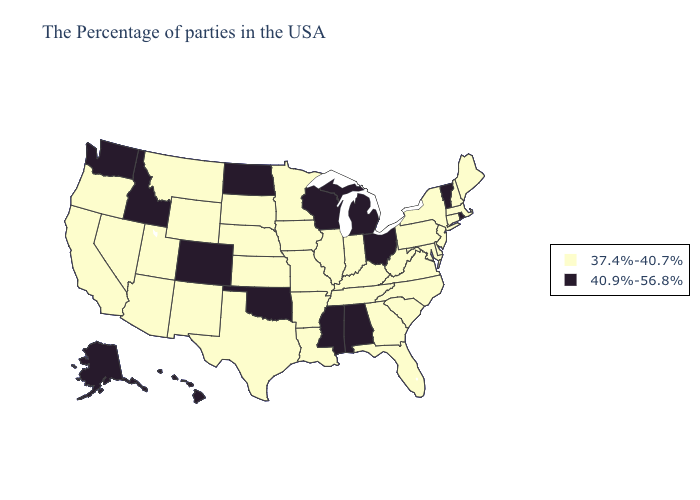Name the states that have a value in the range 37.4%-40.7%?
Answer briefly. Maine, Massachusetts, New Hampshire, Connecticut, New York, New Jersey, Delaware, Maryland, Pennsylvania, Virginia, North Carolina, South Carolina, West Virginia, Florida, Georgia, Kentucky, Indiana, Tennessee, Illinois, Louisiana, Missouri, Arkansas, Minnesota, Iowa, Kansas, Nebraska, Texas, South Dakota, Wyoming, New Mexico, Utah, Montana, Arizona, Nevada, California, Oregon. What is the value of Indiana?
Answer briefly. 37.4%-40.7%. What is the highest value in states that border Louisiana?
Keep it brief. 40.9%-56.8%. Does Ohio have the lowest value in the USA?
Write a very short answer. No. Name the states that have a value in the range 37.4%-40.7%?
Write a very short answer. Maine, Massachusetts, New Hampshire, Connecticut, New York, New Jersey, Delaware, Maryland, Pennsylvania, Virginia, North Carolina, South Carolina, West Virginia, Florida, Georgia, Kentucky, Indiana, Tennessee, Illinois, Louisiana, Missouri, Arkansas, Minnesota, Iowa, Kansas, Nebraska, Texas, South Dakota, Wyoming, New Mexico, Utah, Montana, Arizona, Nevada, California, Oregon. Which states hav the highest value in the Northeast?
Write a very short answer. Rhode Island, Vermont. Name the states that have a value in the range 40.9%-56.8%?
Keep it brief. Rhode Island, Vermont, Ohio, Michigan, Alabama, Wisconsin, Mississippi, Oklahoma, North Dakota, Colorado, Idaho, Washington, Alaska, Hawaii. Does Alabama have the lowest value in the South?
Concise answer only. No. Does West Virginia have the highest value in the USA?
Short answer required. No. Name the states that have a value in the range 37.4%-40.7%?
Give a very brief answer. Maine, Massachusetts, New Hampshire, Connecticut, New York, New Jersey, Delaware, Maryland, Pennsylvania, Virginia, North Carolina, South Carolina, West Virginia, Florida, Georgia, Kentucky, Indiana, Tennessee, Illinois, Louisiana, Missouri, Arkansas, Minnesota, Iowa, Kansas, Nebraska, Texas, South Dakota, Wyoming, New Mexico, Utah, Montana, Arizona, Nevada, California, Oregon. Which states have the lowest value in the USA?
Write a very short answer. Maine, Massachusetts, New Hampshire, Connecticut, New York, New Jersey, Delaware, Maryland, Pennsylvania, Virginia, North Carolina, South Carolina, West Virginia, Florida, Georgia, Kentucky, Indiana, Tennessee, Illinois, Louisiana, Missouri, Arkansas, Minnesota, Iowa, Kansas, Nebraska, Texas, South Dakota, Wyoming, New Mexico, Utah, Montana, Arizona, Nevada, California, Oregon. Name the states that have a value in the range 37.4%-40.7%?
Be succinct. Maine, Massachusetts, New Hampshire, Connecticut, New York, New Jersey, Delaware, Maryland, Pennsylvania, Virginia, North Carolina, South Carolina, West Virginia, Florida, Georgia, Kentucky, Indiana, Tennessee, Illinois, Louisiana, Missouri, Arkansas, Minnesota, Iowa, Kansas, Nebraska, Texas, South Dakota, Wyoming, New Mexico, Utah, Montana, Arizona, Nevada, California, Oregon. What is the value of Montana?
Keep it brief. 37.4%-40.7%. Which states have the lowest value in the USA?
Write a very short answer. Maine, Massachusetts, New Hampshire, Connecticut, New York, New Jersey, Delaware, Maryland, Pennsylvania, Virginia, North Carolina, South Carolina, West Virginia, Florida, Georgia, Kentucky, Indiana, Tennessee, Illinois, Louisiana, Missouri, Arkansas, Minnesota, Iowa, Kansas, Nebraska, Texas, South Dakota, Wyoming, New Mexico, Utah, Montana, Arizona, Nevada, California, Oregon. What is the value of North Dakota?
Keep it brief. 40.9%-56.8%. 